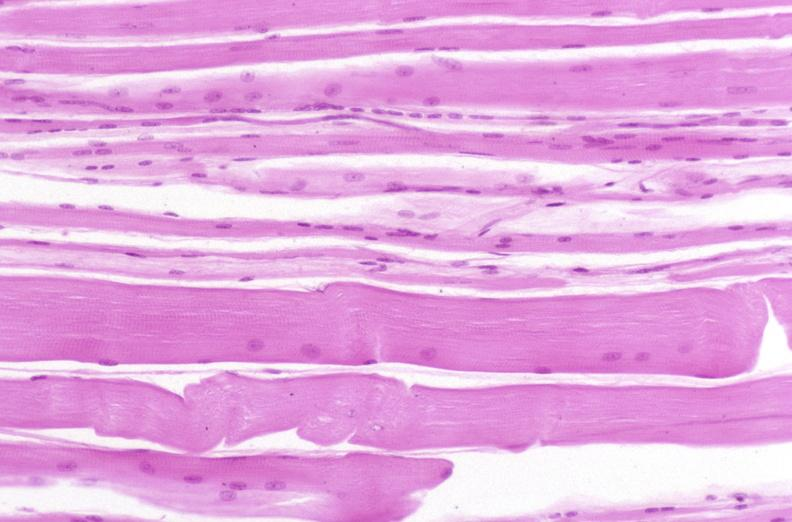does this image show skeletal muscle, atrophy due to immobilization cast?
Answer the question using a single word or phrase. Yes 